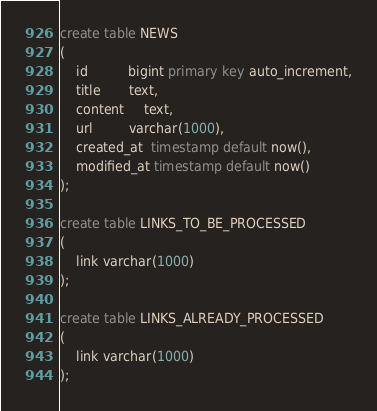Convert code to text. <code><loc_0><loc_0><loc_500><loc_500><_SQL_>create table NEWS
(
    id          bigint primary key auto_increment,
    title       text,
    content     text,
    url         varchar(1000),
    created_at  timestamp default now(),
    modified_at timestamp default now()
);

create table LINKS_TO_BE_PROCESSED
(
    link varchar(1000)
);

create table LINKS_ALREADY_PROCESSED
(
    link varchar(1000)
);

</code> 